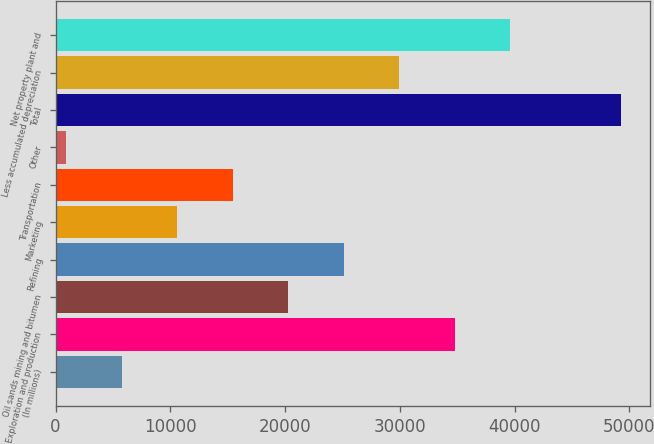<chart> <loc_0><loc_0><loc_500><loc_500><bar_chart><fcel>(In millions)<fcel>Exploration and production<fcel>Oil sands mining and bitumen<fcel>Refining<fcel>Marketing<fcel>Transportation<fcel>Other<fcel>Total<fcel>Less accumulated depreciation<fcel>Net property plant and<nl><fcel>5787.4<fcel>34799.8<fcel>20293.6<fcel>25129<fcel>10622.8<fcel>15458.2<fcel>952<fcel>49306<fcel>29964.4<fcel>39635.2<nl></chart> 